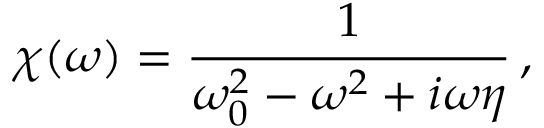<formula> <loc_0><loc_0><loc_500><loc_500>\chi ( \omega ) = \frac { 1 } { \omega _ { 0 } ^ { 2 } - \omega ^ { 2 } + i \omega \eta } \, ,</formula> 